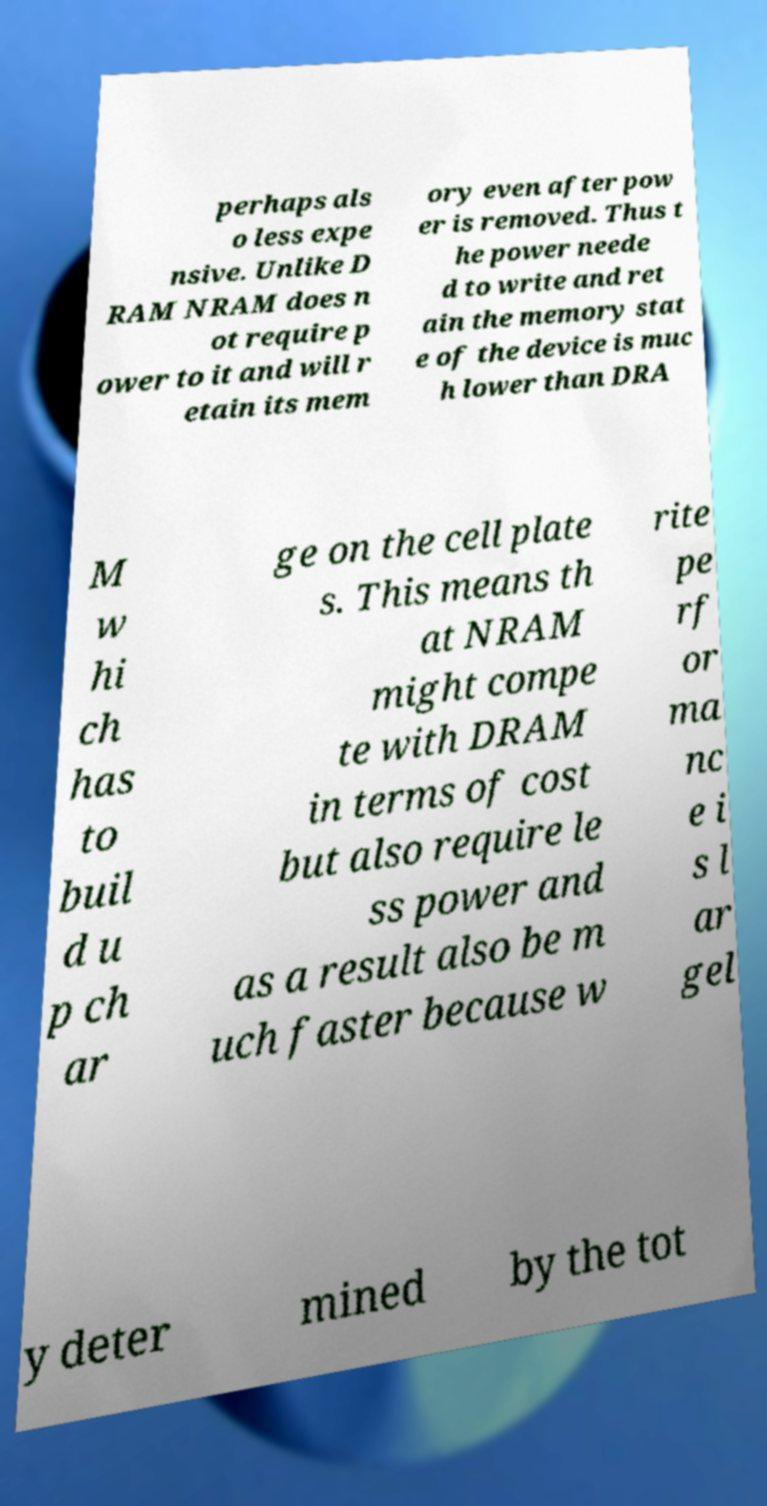Can you read and provide the text displayed in the image?This photo seems to have some interesting text. Can you extract and type it out for me? perhaps als o less expe nsive. Unlike D RAM NRAM does n ot require p ower to it and will r etain its mem ory even after pow er is removed. Thus t he power neede d to write and ret ain the memory stat e of the device is muc h lower than DRA M w hi ch has to buil d u p ch ar ge on the cell plate s. This means th at NRAM might compe te with DRAM in terms of cost but also require le ss power and as a result also be m uch faster because w rite pe rf or ma nc e i s l ar gel y deter mined by the tot 